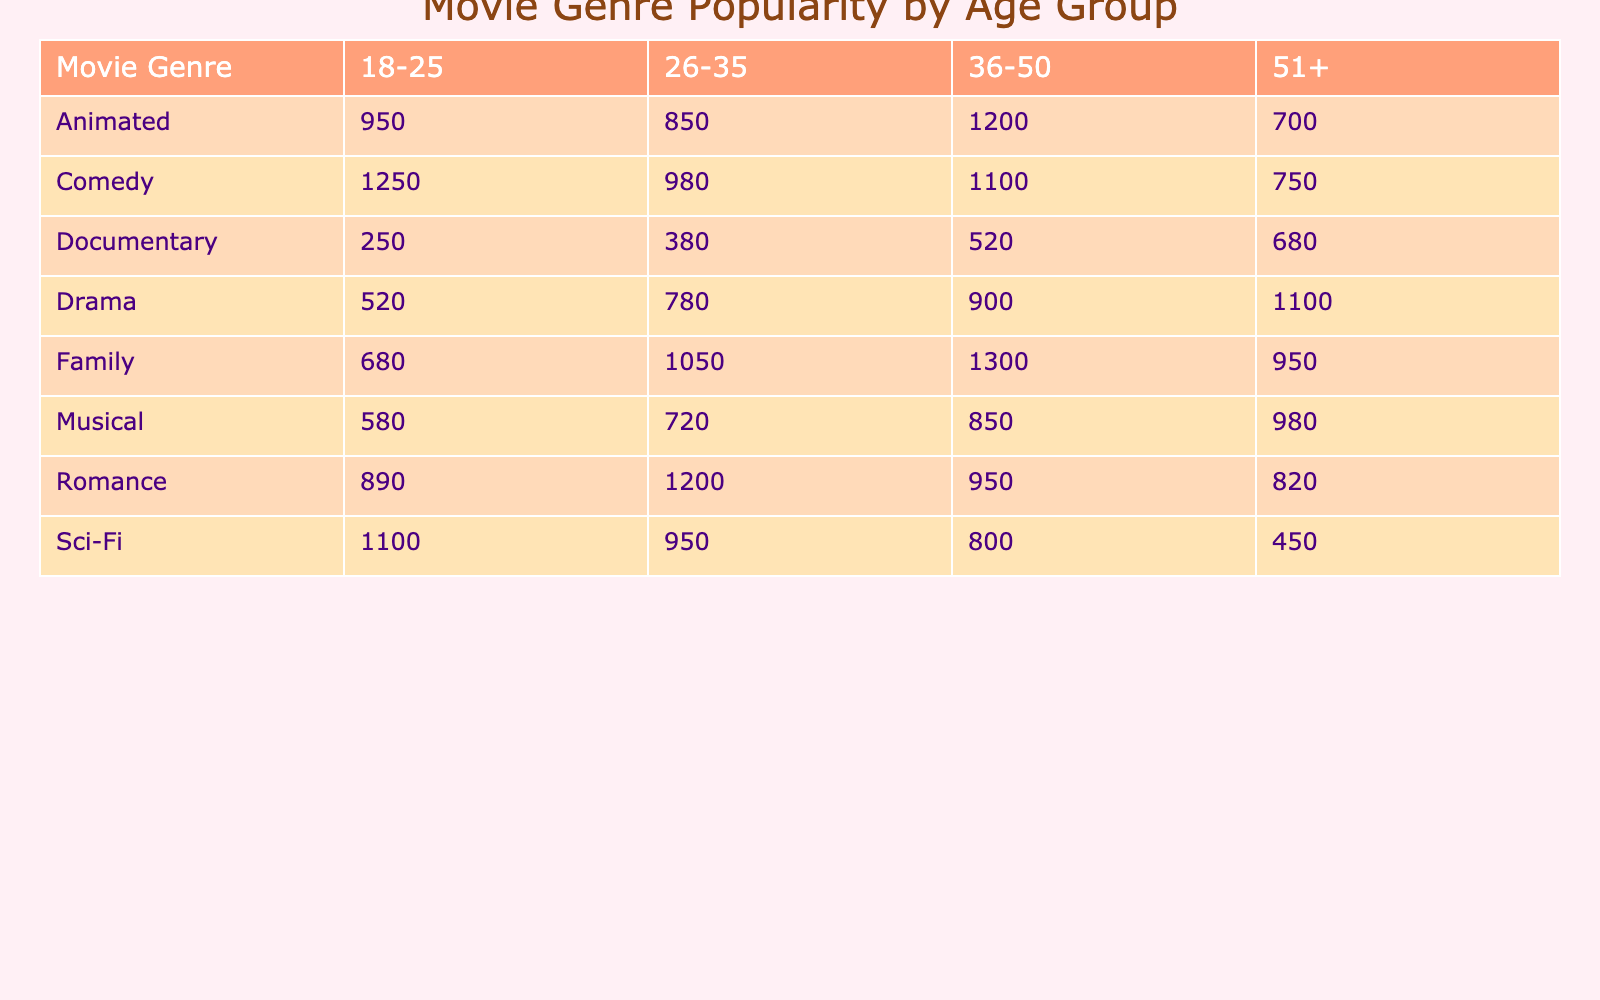What genre sold the most tickets in the 36-50 age group? In the 36-50 age group, the ticket sales for each genre are as follows: Comedy (1100), Romance (950), Family (1300), Drama (900), Animated (1200), Sci-Fi (800), Documentary (520), and Musical (850). The highest value is Family with 1300 tickets sold.
Answer: Family How many tickets were sold for Comedy movies across all age groups? The ticket sales for Comedy movies in each age group are: 1250 (18-25), 980 (26-35), 1100 (36-50), and 750 (51+). Summing these amounts gives: 1250 + 980 + 1100 + 750 = 4080.
Answer: 4080 Is the average ticket price for Animated movies higher than for Drama movies? The average ticket price for Animated movies is 12.50, 13.00, 11.75, and 14.00 across age groups, averaging to (12.50 + 13.00 + 11.75 + 14.00)/4 = 12.56. The average for Drama is 12.50, 13.00, 11.75, and 14.00, averaging to (12.50 + 13.00 + 11.75 + 14.00)/4 = 12.56. Since both values are equal, the answer is no.
Answer: No Which age group had the least tickets sold for Family movies? The sales of Family movies by age group are: 680 (18-25), 1050 (26-35), 1300 (36-50), and 950 (51+). Among these, 680 is the smallest number, representing the 18-25 age group.
Answer: 18-25 If you combine the sales of Romance and Comedy movies for the 51+ age group, what is the total? For Romance in the 51+ age group, 820 tickets were sold, and for Comedy, 750 tickets were sold. Adding these gives: 820 + 750 = 1570 tickets sold in total.
Answer: 1570 